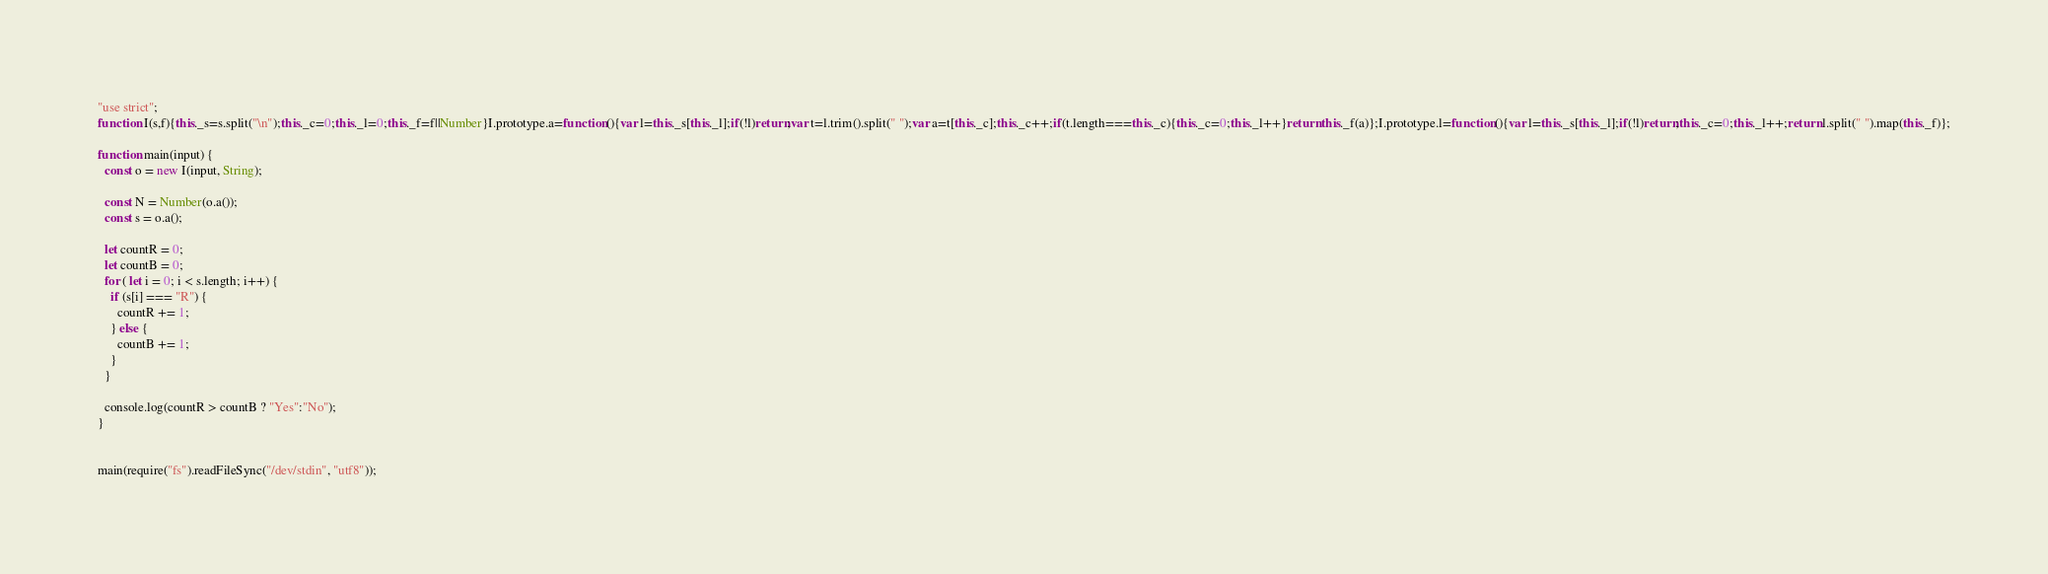Convert code to text. <code><loc_0><loc_0><loc_500><loc_500><_JavaScript_>"use strict";
function I(s,f){this._s=s.split("\n");this._c=0;this._l=0;this._f=f||Number}I.prototype.a=function(){var l=this._s[this._l];if(!l)return;var t=l.trim().split(" ");var a=t[this._c];this._c++;if(t.length===this._c){this._c=0;this._l++}return this._f(a)};I.prototype.l=function(){var l=this._s[this._l];if(!l)return;this._c=0;this._l++;return l.split(" ").map(this._f)};

function main(input) {
  const o = new I(input, String);

  const N = Number(o.a());
  const s = o.a();

  let countR = 0;
  let countB = 0;
  for ( let i = 0; i < s.length; i++) {
    if (s[i] === "R") {
      countR += 1;
    } else {
      countB += 1;
    }
  }

  console.log(countR > countB ? "Yes":"No");
}


main(require("fs").readFileSync("/dev/stdin", "utf8"));
</code> 